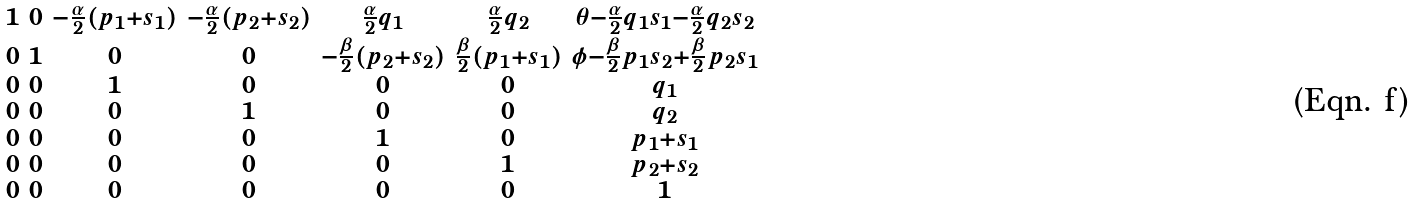Convert formula to latex. <formula><loc_0><loc_0><loc_500><loc_500>\begin{smallmatrix} 1 & 0 & - \frac { \alpha } { 2 } ( p _ { 1 } + s _ { 1 } ) & - \frac { \alpha } { 2 } ( p _ { 2 } + s _ { 2 } ) & \frac { \alpha } { 2 } q _ { 1 } & \frac { \alpha } { 2 } q _ { 2 } & \theta - \frac { \alpha } { 2 } q _ { 1 } s _ { 1 } - \frac { \alpha } { 2 } q _ { 2 } s _ { 2 } \\ 0 & 1 & 0 & 0 & - \frac { \beta } { 2 } ( p _ { 2 } + s _ { 2 } ) & \frac { \beta } { 2 } ( p _ { 1 } + s _ { 1 } ) & \phi - \frac { \beta } { 2 } p _ { 1 } s _ { 2 } + \frac { \beta } { 2 } p _ { 2 } s _ { 1 } \\ 0 & 0 & 1 & 0 & 0 & 0 & q _ { 1 } \\ 0 & 0 & 0 & 1 & 0 & 0 & q _ { 2 } \\ 0 & 0 & 0 & 0 & 1 & 0 & p _ { 1 } + s _ { 1 } \\ 0 & 0 & 0 & 0 & 0 & 1 & p _ { 2 } + s _ { 2 } \\ 0 & 0 & 0 & 0 & 0 & 0 & 1 \end{smallmatrix}</formula> 